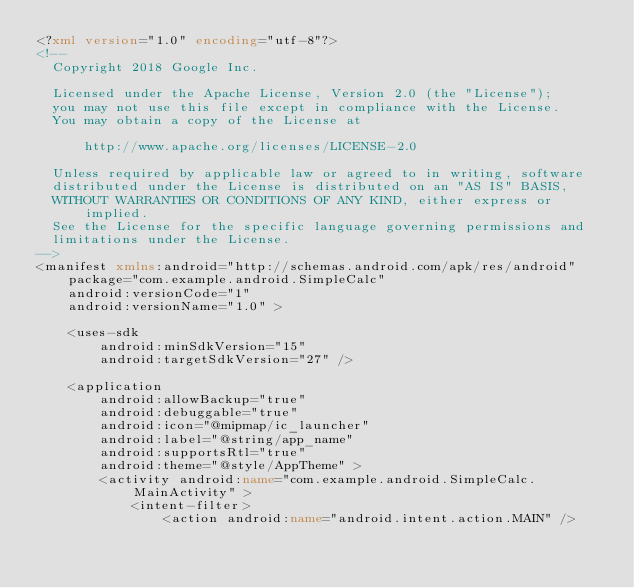Convert code to text. <code><loc_0><loc_0><loc_500><loc_500><_XML_><?xml version="1.0" encoding="utf-8"?>
<!--
  Copyright 2018 Google Inc.

  Licensed under the Apache License, Version 2.0 (the "License");
  you may not use this file except in compliance with the License.
  You may obtain a copy of the License at

      http://www.apache.org/licenses/LICENSE-2.0

  Unless required by applicable law or agreed to in writing, software
  distributed under the License is distributed on an "AS IS" BASIS,
  WITHOUT WARRANTIES OR CONDITIONS OF ANY KIND, either express or implied.
  See the License for the specific language governing permissions and
  limitations under the License.
-->
<manifest xmlns:android="http://schemas.android.com/apk/res/android"
    package="com.example.android.SimpleCalc"
    android:versionCode="1"
    android:versionName="1.0" >

    <uses-sdk
        android:minSdkVersion="15"
        android:targetSdkVersion="27" />

    <application
        android:allowBackup="true"
        android:debuggable="true"
        android:icon="@mipmap/ic_launcher"
        android:label="@string/app_name"
        android:supportsRtl="true"
        android:theme="@style/AppTheme" >
        <activity android:name="com.example.android.SimpleCalc.MainActivity" >
            <intent-filter>
                <action android:name="android.intent.action.MAIN" />
</code> 